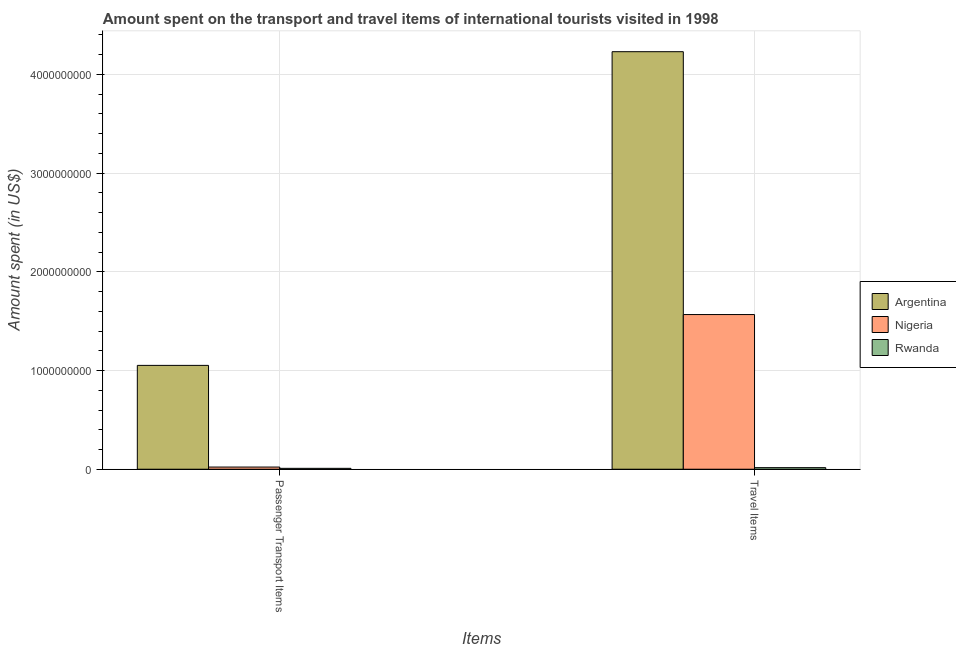How many different coloured bars are there?
Your response must be concise. 3. How many groups of bars are there?
Give a very brief answer. 2. Are the number of bars per tick equal to the number of legend labels?
Keep it short and to the point. Yes. Are the number of bars on each tick of the X-axis equal?
Give a very brief answer. Yes. How many bars are there on the 2nd tick from the left?
Offer a very short reply. 3. What is the label of the 2nd group of bars from the left?
Your answer should be very brief. Travel Items. What is the amount spent on passenger transport items in Rwanda?
Make the answer very short. 9.00e+06. Across all countries, what is the maximum amount spent on passenger transport items?
Provide a succinct answer. 1.05e+09. Across all countries, what is the minimum amount spent on passenger transport items?
Make the answer very short. 9.00e+06. In which country was the amount spent in travel items maximum?
Your answer should be compact. Argentina. In which country was the amount spent in travel items minimum?
Provide a succinct answer. Rwanda. What is the total amount spent in travel items in the graph?
Your response must be concise. 5.81e+09. What is the difference between the amount spent on passenger transport items in Nigeria and that in Argentina?
Your answer should be compact. -1.03e+09. What is the difference between the amount spent on passenger transport items in Nigeria and the amount spent in travel items in Rwanda?
Your answer should be very brief. 6.00e+06. What is the average amount spent in travel items per country?
Your answer should be compact. 1.94e+09. What is the difference between the amount spent on passenger transport items and amount spent in travel items in Nigeria?
Offer a very short reply. -1.54e+09. What is the ratio of the amount spent in travel items in Nigeria to that in Rwanda?
Offer a very short reply. 97.94. Is the amount spent in travel items in Rwanda less than that in Nigeria?
Make the answer very short. Yes. What does the 3rd bar from the left in Travel Items represents?
Provide a succinct answer. Rwanda. What does the 2nd bar from the right in Travel Items represents?
Your response must be concise. Nigeria. Are all the bars in the graph horizontal?
Ensure brevity in your answer.  No. Are the values on the major ticks of Y-axis written in scientific E-notation?
Your answer should be compact. No. Does the graph contain grids?
Make the answer very short. Yes. Where does the legend appear in the graph?
Keep it short and to the point. Center right. How are the legend labels stacked?
Provide a succinct answer. Vertical. What is the title of the graph?
Make the answer very short. Amount spent on the transport and travel items of international tourists visited in 1998. What is the label or title of the X-axis?
Offer a very short reply. Items. What is the label or title of the Y-axis?
Give a very brief answer. Amount spent (in US$). What is the Amount spent (in US$) in Argentina in Passenger Transport Items?
Offer a very short reply. 1.05e+09. What is the Amount spent (in US$) of Nigeria in Passenger Transport Items?
Offer a very short reply. 2.20e+07. What is the Amount spent (in US$) in Rwanda in Passenger Transport Items?
Ensure brevity in your answer.  9.00e+06. What is the Amount spent (in US$) in Argentina in Travel Items?
Keep it short and to the point. 4.23e+09. What is the Amount spent (in US$) in Nigeria in Travel Items?
Provide a succinct answer. 1.57e+09. What is the Amount spent (in US$) of Rwanda in Travel Items?
Provide a short and direct response. 1.60e+07. Across all Items, what is the maximum Amount spent (in US$) in Argentina?
Give a very brief answer. 4.23e+09. Across all Items, what is the maximum Amount spent (in US$) of Nigeria?
Your response must be concise. 1.57e+09. Across all Items, what is the maximum Amount spent (in US$) of Rwanda?
Give a very brief answer. 1.60e+07. Across all Items, what is the minimum Amount spent (in US$) in Argentina?
Provide a short and direct response. 1.05e+09. Across all Items, what is the minimum Amount spent (in US$) of Nigeria?
Provide a short and direct response. 2.20e+07. Across all Items, what is the minimum Amount spent (in US$) of Rwanda?
Make the answer very short. 9.00e+06. What is the total Amount spent (in US$) in Argentina in the graph?
Ensure brevity in your answer.  5.28e+09. What is the total Amount spent (in US$) of Nigeria in the graph?
Your response must be concise. 1.59e+09. What is the total Amount spent (in US$) in Rwanda in the graph?
Provide a short and direct response. 2.50e+07. What is the difference between the Amount spent (in US$) in Argentina in Passenger Transport Items and that in Travel Items?
Offer a terse response. -3.18e+09. What is the difference between the Amount spent (in US$) of Nigeria in Passenger Transport Items and that in Travel Items?
Provide a succinct answer. -1.54e+09. What is the difference between the Amount spent (in US$) of Rwanda in Passenger Transport Items and that in Travel Items?
Give a very brief answer. -7.00e+06. What is the difference between the Amount spent (in US$) of Argentina in Passenger Transport Items and the Amount spent (in US$) of Nigeria in Travel Items?
Offer a very short reply. -5.15e+08. What is the difference between the Amount spent (in US$) in Argentina in Passenger Transport Items and the Amount spent (in US$) in Rwanda in Travel Items?
Give a very brief answer. 1.04e+09. What is the difference between the Amount spent (in US$) of Nigeria in Passenger Transport Items and the Amount spent (in US$) of Rwanda in Travel Items?
Offer a terse response. 6.00e+06. What is the average Amount spent (in US$) in Argentina per Items?
Your answer should be compact. 2.64e+09. What is the average Amount spent (in US$) in Nigeria per Items?
Offer a terse response. 7.94e+08. What is the average Amount spent (in US$) in Rwanda per Items?
Your answer should be compact. 1.25e+07. What is the difference between the Amount spent (in US$) of Argentina and Amount spent (in US$) of Nigeria in Passenger Transport Items?
Provide a succinct answer. 1.03e+09. What is the difference between the Amount spent (in US$) in Argentina and Amount spent (in US$) in Rwanda in Passenger Transport Items?
Provide a succinct answer. 1.04e+09. What is the difference between the Amount spent (in US$) in Nigeria and Amount spent (in US$) in Rwanda in Passenger Transport Items?
Provide a short and direct response. 1.30e+07. What is the difference between the Amount spent (in US$) in Argentina and Amount spent (in US$) in Nigeria in Travel Items?
Provide a short and direct response. 2.66e+09. What is the difference between the Amount spent (in US$) of Argentina and Amount spent (in US$) of Rwanda in Travel Items?
Keep it short and to the point. 4.21e+09. What is the difference between the Amount spent (in US$) of Nigeria and Amount spent (in US$) of Rwanda in Travel Items?
Your response must be concise. 1.55e+09. What is the ratio of the Amount spent (in US$) of Argentina in Passenger Transport Items to that in Travel Items?
Your response must be concise. 0.25. What is the ratio of the Amount spent (in US$) of Nigeria in Passenger Transport Items to that in Travel Items?
Keep it short and to the point. 0.01. What is the ratio of the Amount spent (in US$) of Rwanda in Passenger Transport Items to that in Travel Items?
Keep it short and to the point. 0.56. What is the difference between the highest and the second highest Amount spent (in US$) of Argentina?
Offer a very short reply. 3.18e+09. What is the difference between the highest and the second highest Amount spent (in US$) of Nigeria?
Provide a succinct answer. 1.54e+09. What is the difference between the highest and the lowest Amount spent (in US$) of Argentina?
Make the answer very short. 3.18e+09. What is the difference between the highest and the lowest Amount spent (in US$) in Nigeria?
Make the answer very short. 1.54e+09. What is the difference between the highest and the lowest Amount spent (in US$) of Rwanda?
Ensure brevity in your answer.  7.00e+06. 